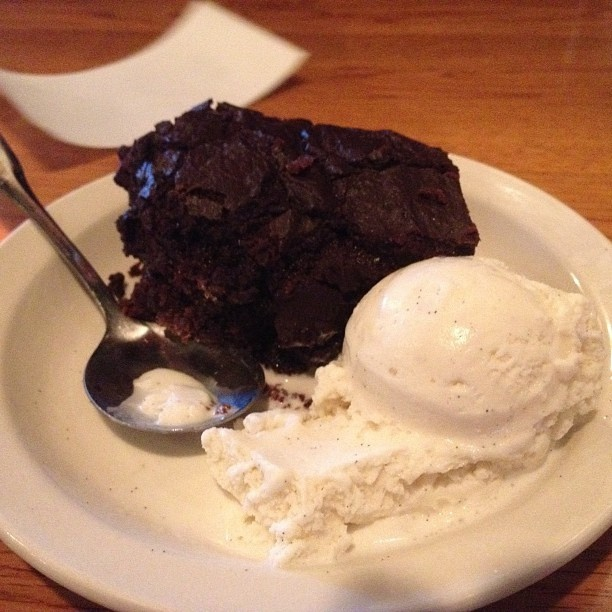Describe the objects in this image and their specific colors. I can see dining table in tan, black, brown, and maroon tones, cake in brown, tan, and beige tones, cake in brown, black, maroon, and tan tones, and spoon in brown, black, maroon, and tan tones in this image. 